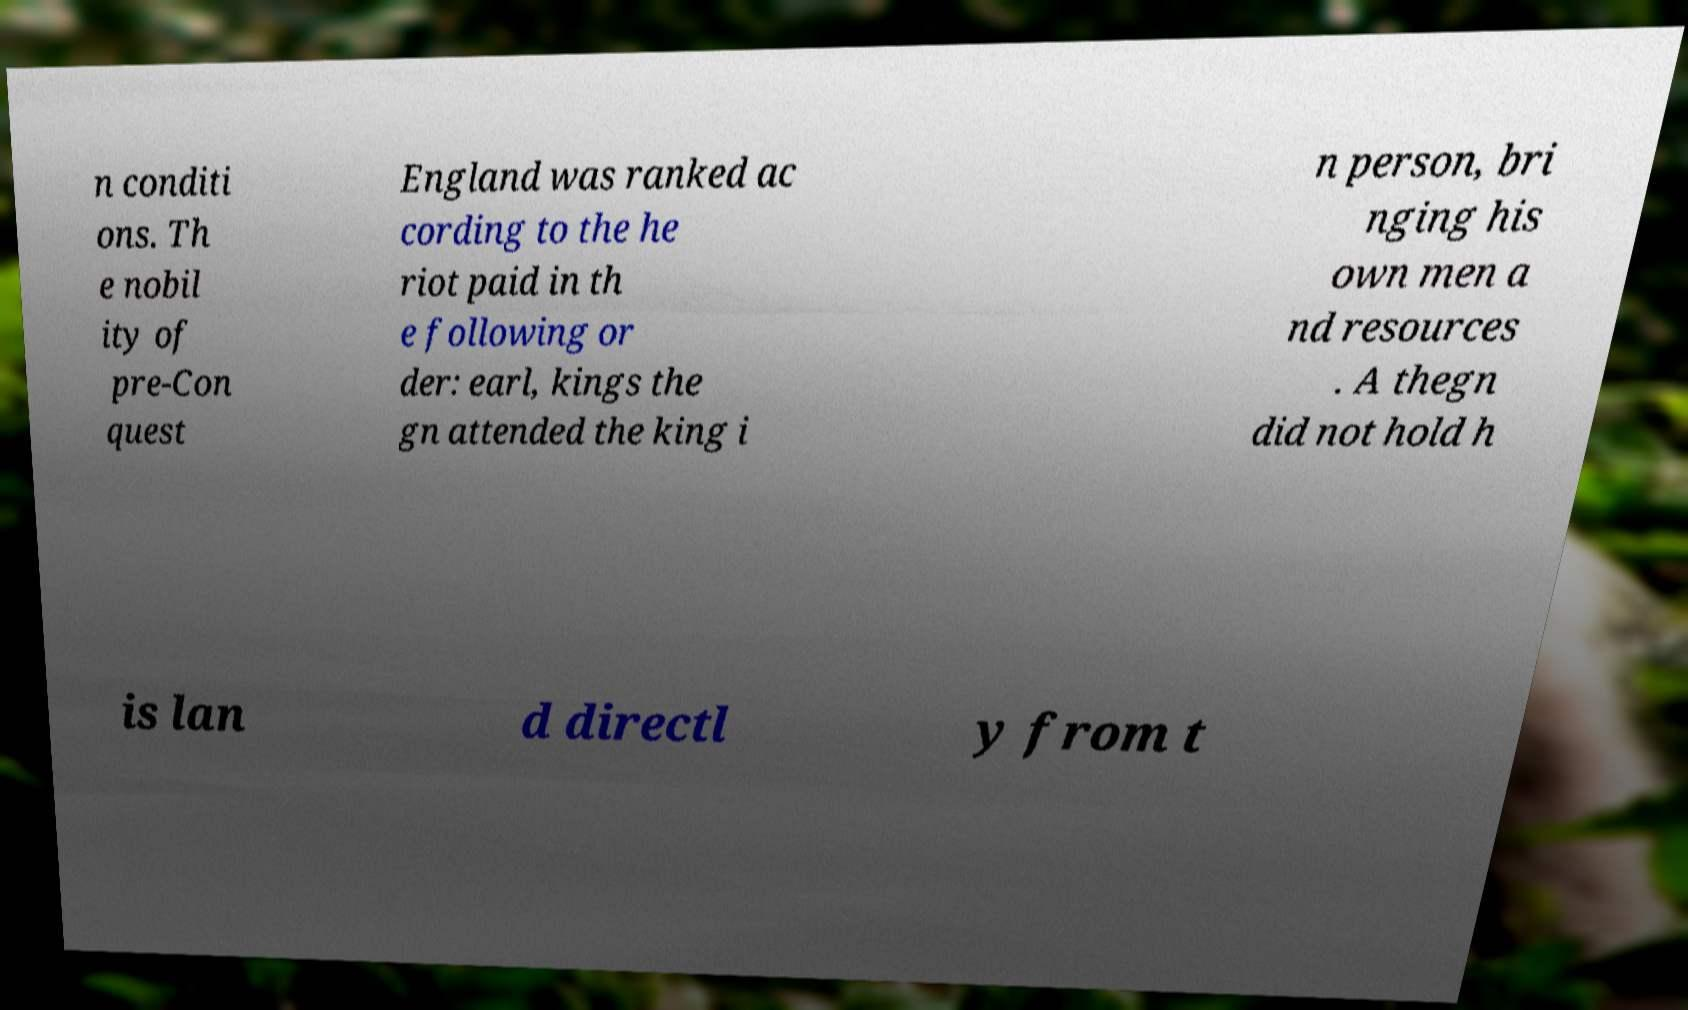Could you assist in decoding the text presented in this image and type it out clearly? n conditi ons. Th e nobil ity of pre-Con quest England was ranked ac cording to the he riot paid in th e following or der: earl, kings the gn attended the king i n person, bri nging his own men a nd resources . A thegn did not hold h is lan d directl y from t 